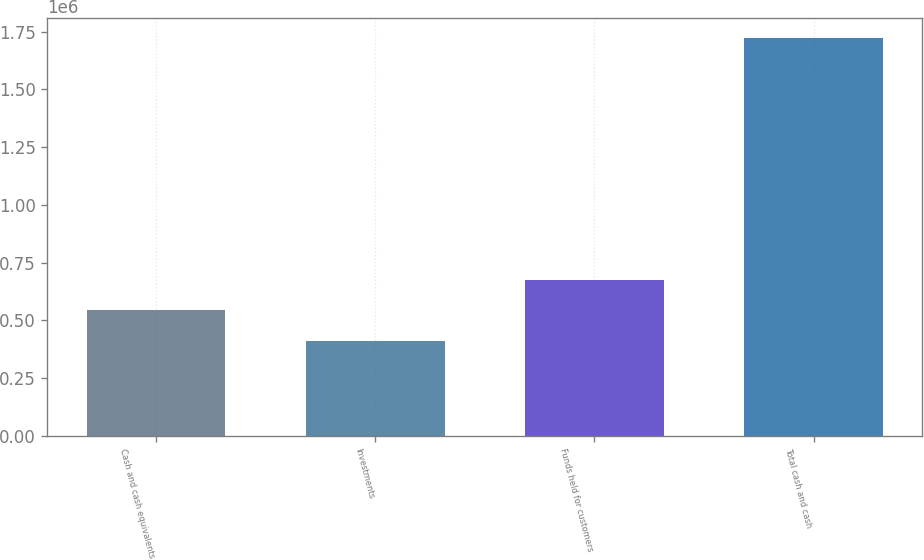<chart> <loc_0><loc_0><loc_500><loc_500><bar_chart><fcel>Cash and cash equivalents<fcel>Investments<fcel>Funds held for customers<fcel>Total cash and cash<nl><fcel>543315<fcel>412075<fcel>674555<fcel>1.72447e+06<nl></chart> 